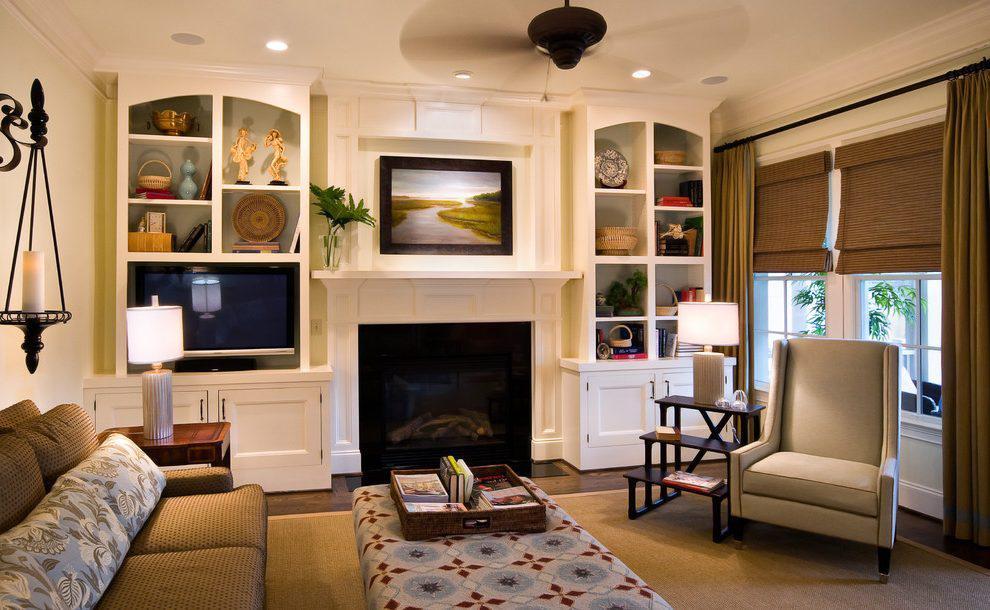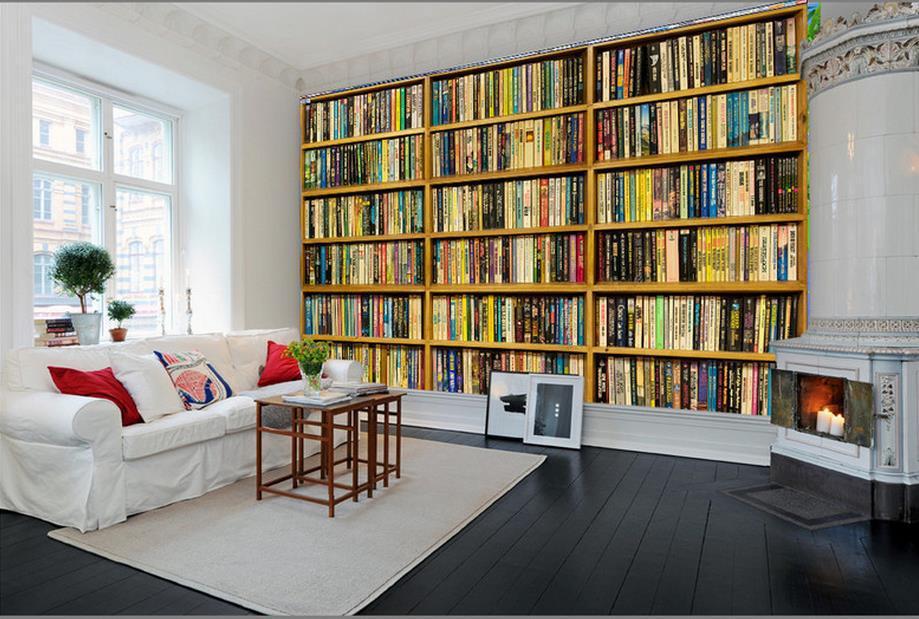The first image is the image on the left, the second image is the image on the right. For the images displayed, is the sentence "In one image, bookcases along a wall flank a fireplace, over which hangs one framed picture." factually correct? Answer yes or no. Yes. The first image is the image on the left, the second image is the image on the right. Assess this claim about the two images: "A window is visible behind a seating that is near to a bookcase.". Correct or not? Answer yes or no. Yes. 